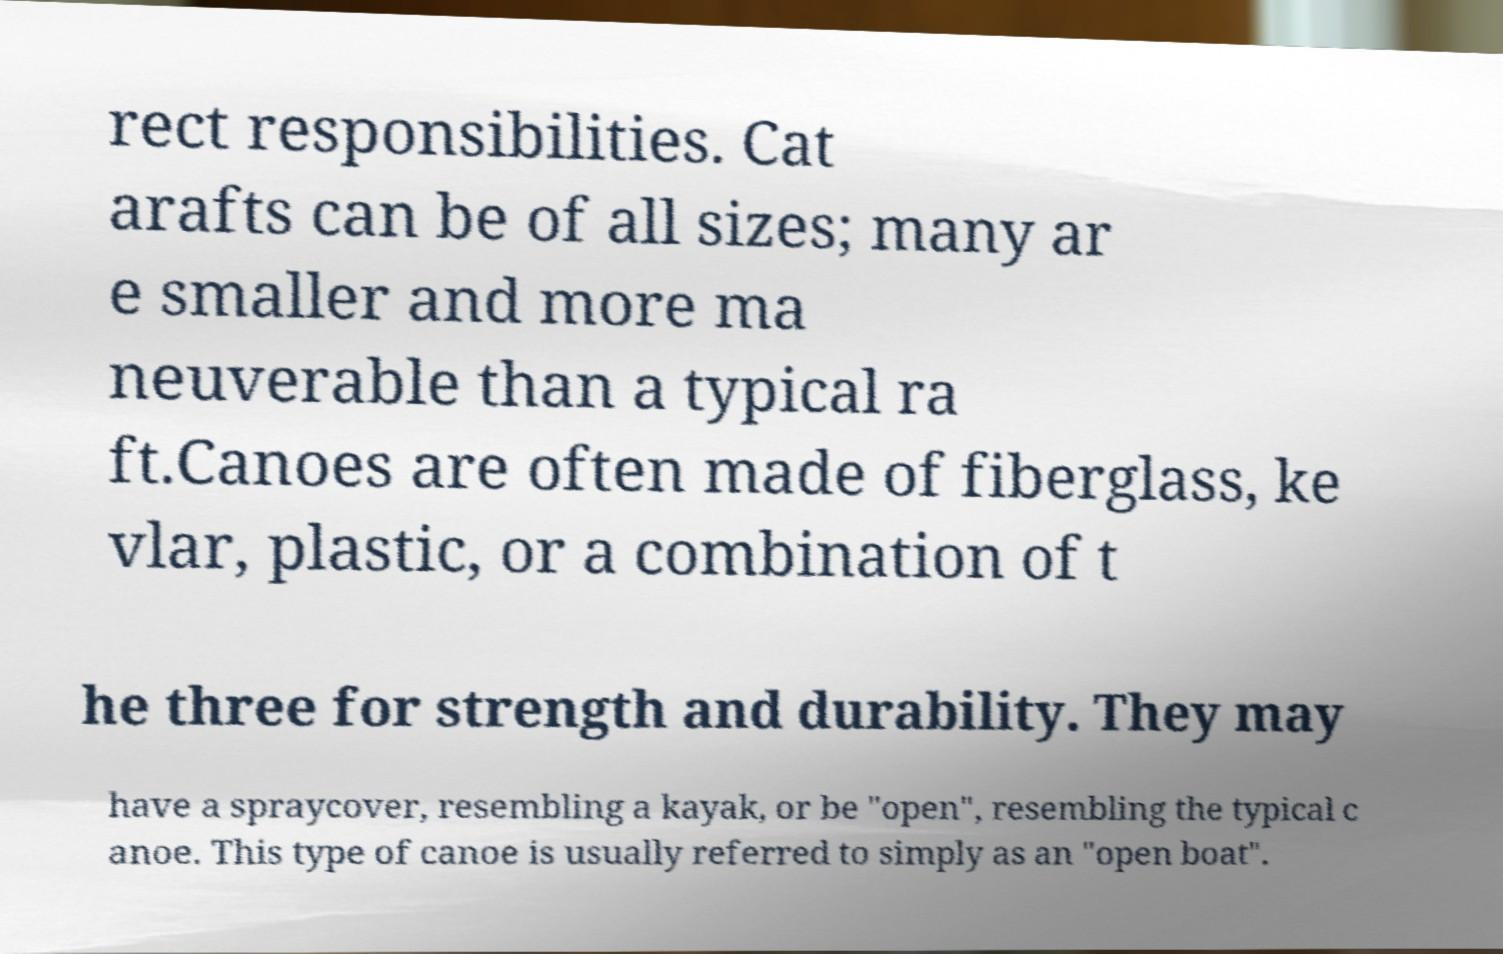Can you read and provide the text displayed in the image?This photo seems to have some interesting text. Can you extract and type it out for me? rect responsibilities. Cat arafts can be of all sizes; many ar e smaller and more ma neuverable than a typical ra ft.Canoes are often made of fiberglass, ke vlar, plastic, or a combination of t he three for strength and durability. They may have a spraycover, resembling a kayak, or be "open", resembling the typical c anoe. This type of canoe is usually referred to simply as an "open boat". 